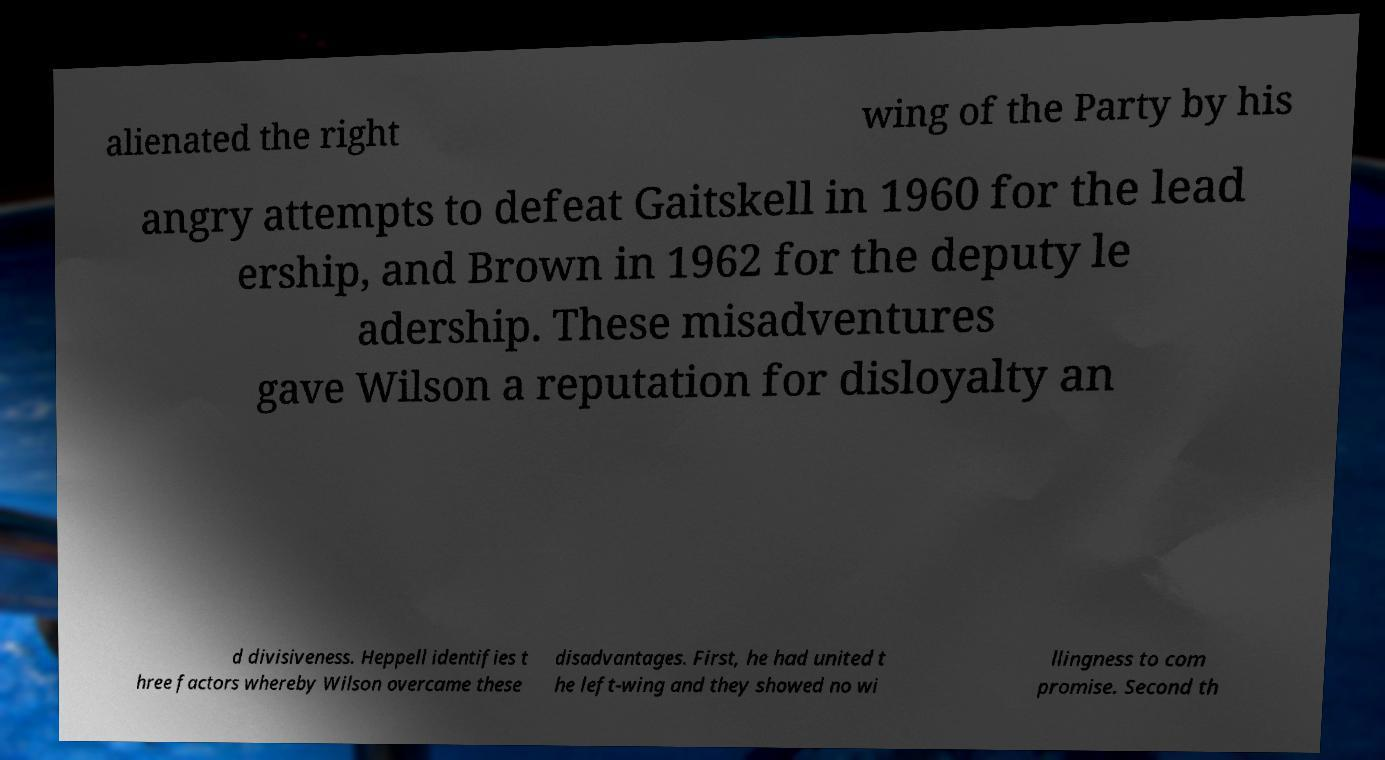Could you extract and type out the text from this image? alienated the right wing of the Party by his angry attempts to defeat Gaitskell in 1960 for the lead ership, and Brown in 1962 for the deputy le adership. These misadventures gave Wilson a reputation for disloyalty an d divisiveness. Heppell identifies t hree factors whereby Wilson overcame these disadvantages. First, he had united t he left-wing and they showed no wi llingness to com promise. Second th 